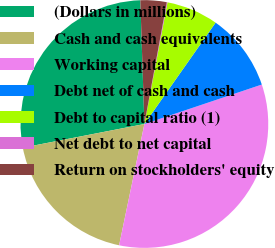Convert chart. <chart><loc_0><loc_0><loc_500><loc_500><pie_chart><fcel>(Dollars in millions)<fcel>Cash and cash equivalents<fcel>Working capital<fcel>Debt net of cash and cash<fcel>Debt to capital ratio (1)<fcel>Net debt to net capital<fcel>Return on stockholders' equity<nl><fcel>27.53%<fcel>18.67%<fcel>33.43%<fcel>10.09%<fcel>6.76%<fcel>0.09%<fcel>3.42%<nl></chart> 